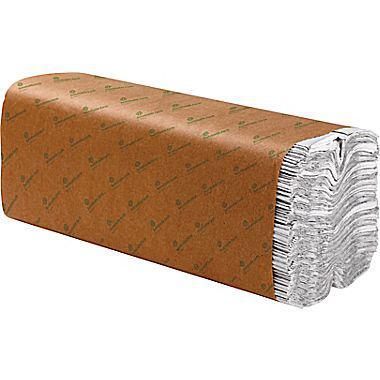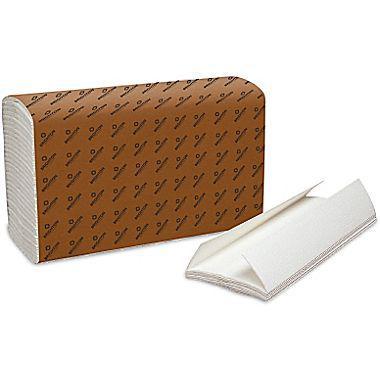The first image is the image on the left, the second image is the image on the right. Given the left and right images, does the statement "There is a least one stack of towels wrapped in brown paper" hold true? Answer yes or no. Yes. The first image is the image on the left, the second image is the image on the right. Given the left and right images, does the statement "One image shows a brown paper-wrapped bundle of folded paper towels with a few unwrapped towels in front of it, but no image includes a tall stack of unwrapped folded paper towels." hold true? Answer yes or no. Yes. 